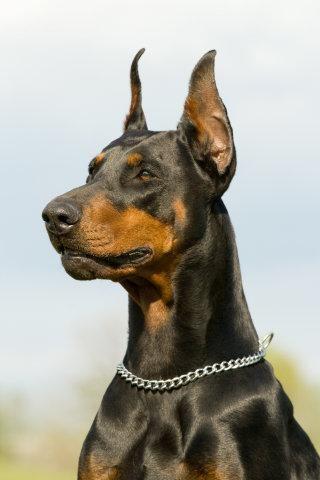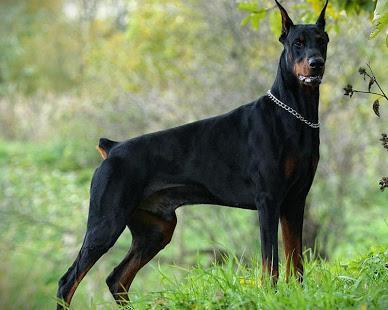The first image is the image on the left, the second image is the image on the right. Evaluate the accuracy of this statement regarding the images: "The right image includes two erect-eared dobermans reclining on fallen leaves, with their bodies turned forward.". Is it true? Answer yes or no. No. The first image is the image on the left, the second image is the image on the right. Considering the images on both sides, is "The right image contains no more than one dog." valid? Answer yes or no. Yes. 